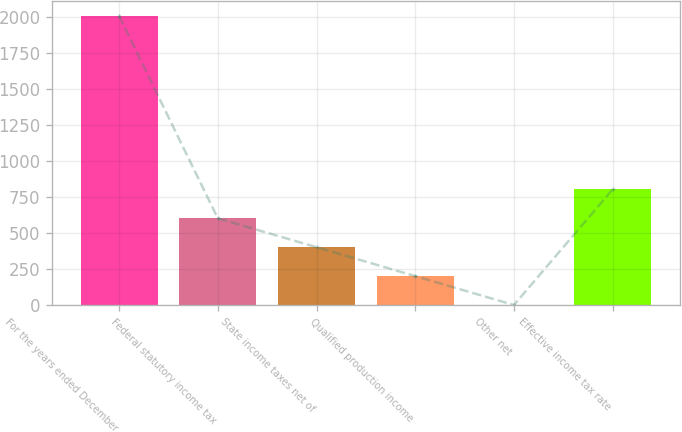Convert chart. <chart><loc_0><loc_0><loc_500><loc_500><bar_chart><fcel>For the years ended December<fcel>Federal statutory income tax<fcel>State income taxes net of<fcel>Qualified production income<fcel>Other net<fcel>Effective income tax rate<nl><fcel>2008<fcel>602.75<fcel>402<fcel>201.25<fcel>0.5<fcel>803.5<nl></chart> 